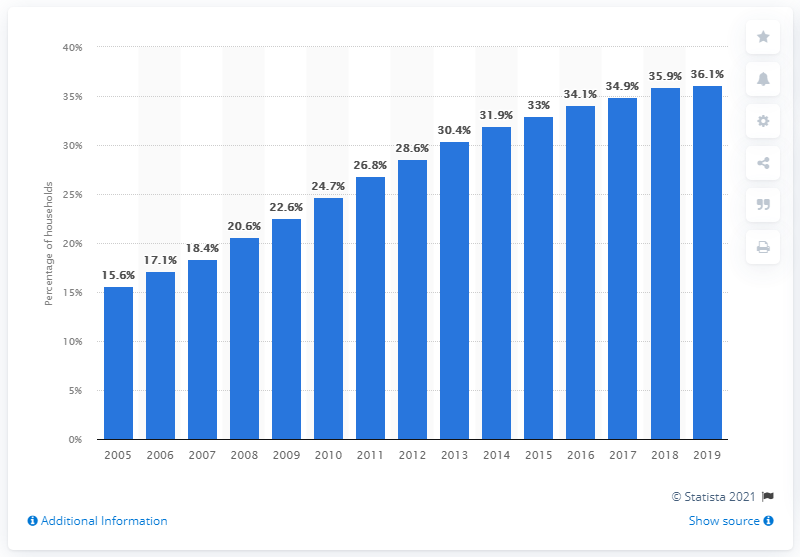Mention a couple of crucial points in this snapshot. In 2019, approximately 36.1% of households in developing countries had a computer at home. In 2019, approximately 36.1% of households in developing countries owned a computer, according to recent data. 